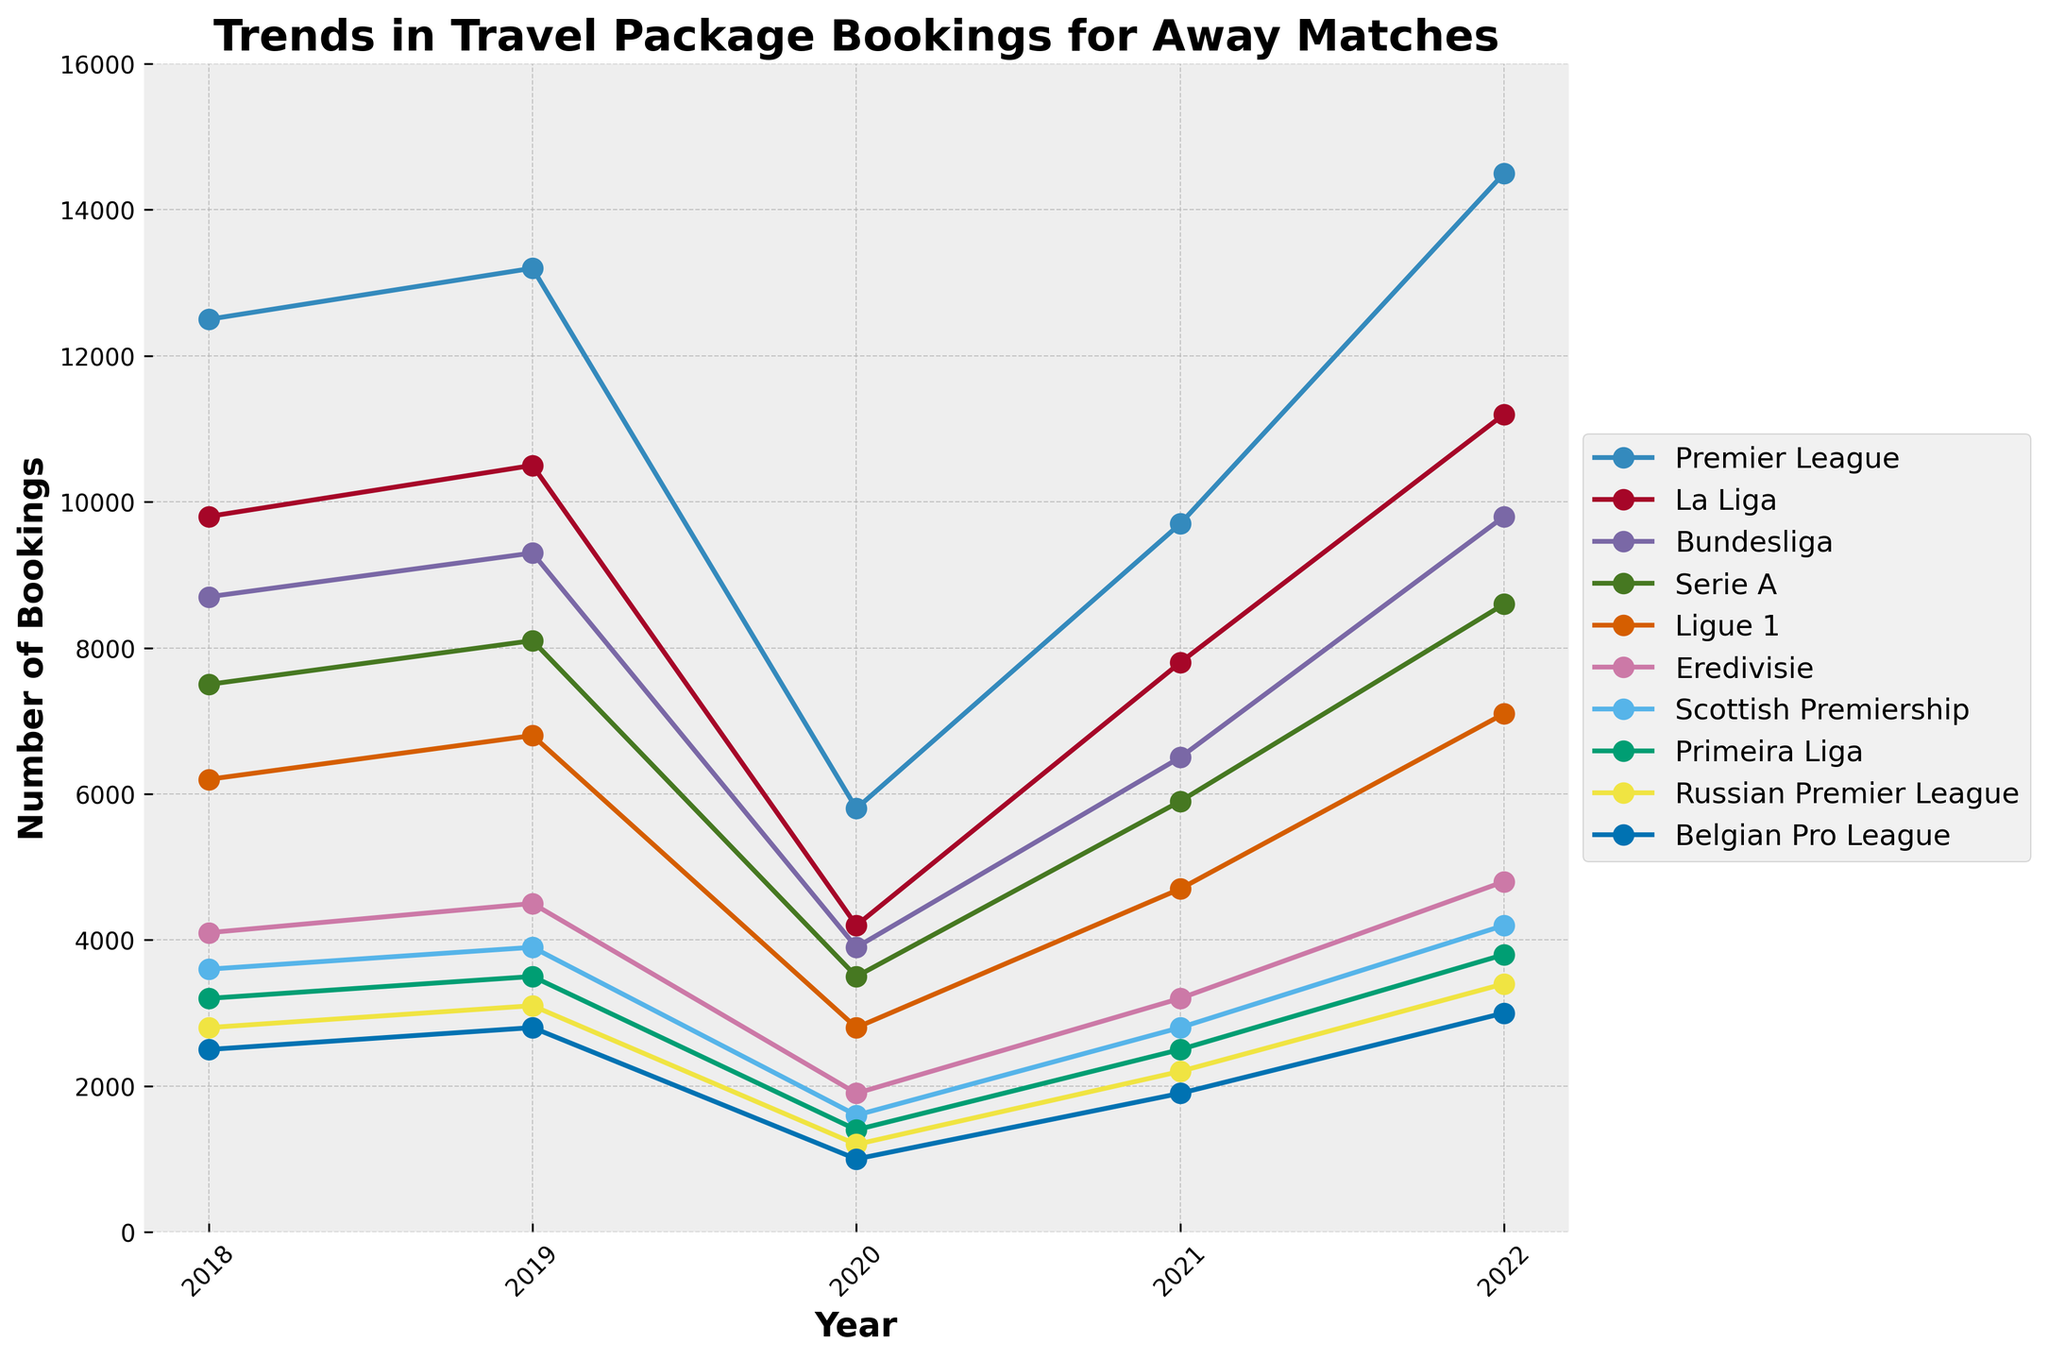What's the highest number of bookings for the Premier League in the given years? To find the highest number of bookings for the Premier League, we look at the plot and identify the peak value of this league's line. The highest value occurs in 2022.
Answer: 14500 Which league had the lowest number of bookings in 2020 and what was that number? Locate the lines corresponding to each league in the year 2020 and find the league with the lowest point. The Belgian Pro League had the lowest with 1000 bookings.
Answer: Belgian Pro League, 1000 Between which two consecutive years did La Liga see the highest increase in bookings? Identify the La Liga line and compare the difference in bookings between consecutive years. The largest increase happened between 2021 and 2022, where bookings increased from 7800 to 11200.
Answer: 2021 to 2022 Compare the number of bookings in 2019 for Ligue 1 and Eredivisie. Which league had more? Look at the values in 2019 for both Ligue 1 and Eredivisie on the chart. Ligue 1 has 6800 and Eredivisie has 4500. Therefore, Ligue 1 had more bookings.
Answer: Ligue 1 By how much did the Bundesliga bookings drop from 2019 to 2020? Identify the points for the Bundesliga in 2019 and 2020 and calculate the decrease. The bookings dropped from 9300 in 2019 to 3900 in 2020. So, 9300 - 3900 = 5400.
Answer: 5400 Which year saw the overall lowest number of bookings across all leagues, and what might be the reason for this? To determine the year with the overall lowest bookings, compare the dips in each line across all years. The lowest numbers are consistently in 2020 due to the COVID-19 pandemic which severely restricted travel.
Answer: 2020, due to COVID-19 If we average the number of bookings in 2022 for the Scottish Premiership, Primeira Liga, and Belgian Pro League, what is the result? For 2022, add the bookings of the Scottish Premiership (4200), Primeira Liga (3800), and Belgian Pro League (3000), then divide by 3. (4200 + 3800 + 3000) / 3 gives an average of 3666.67.
Answer: 3666.67 Which league showed consistent growth in bookings from 2018 to 2022? Check each league's line for a consistent upward trend. The Premier League shows consistent growth from 12500 in 2018 to 14500 in 2022.
Answer: Premier League 